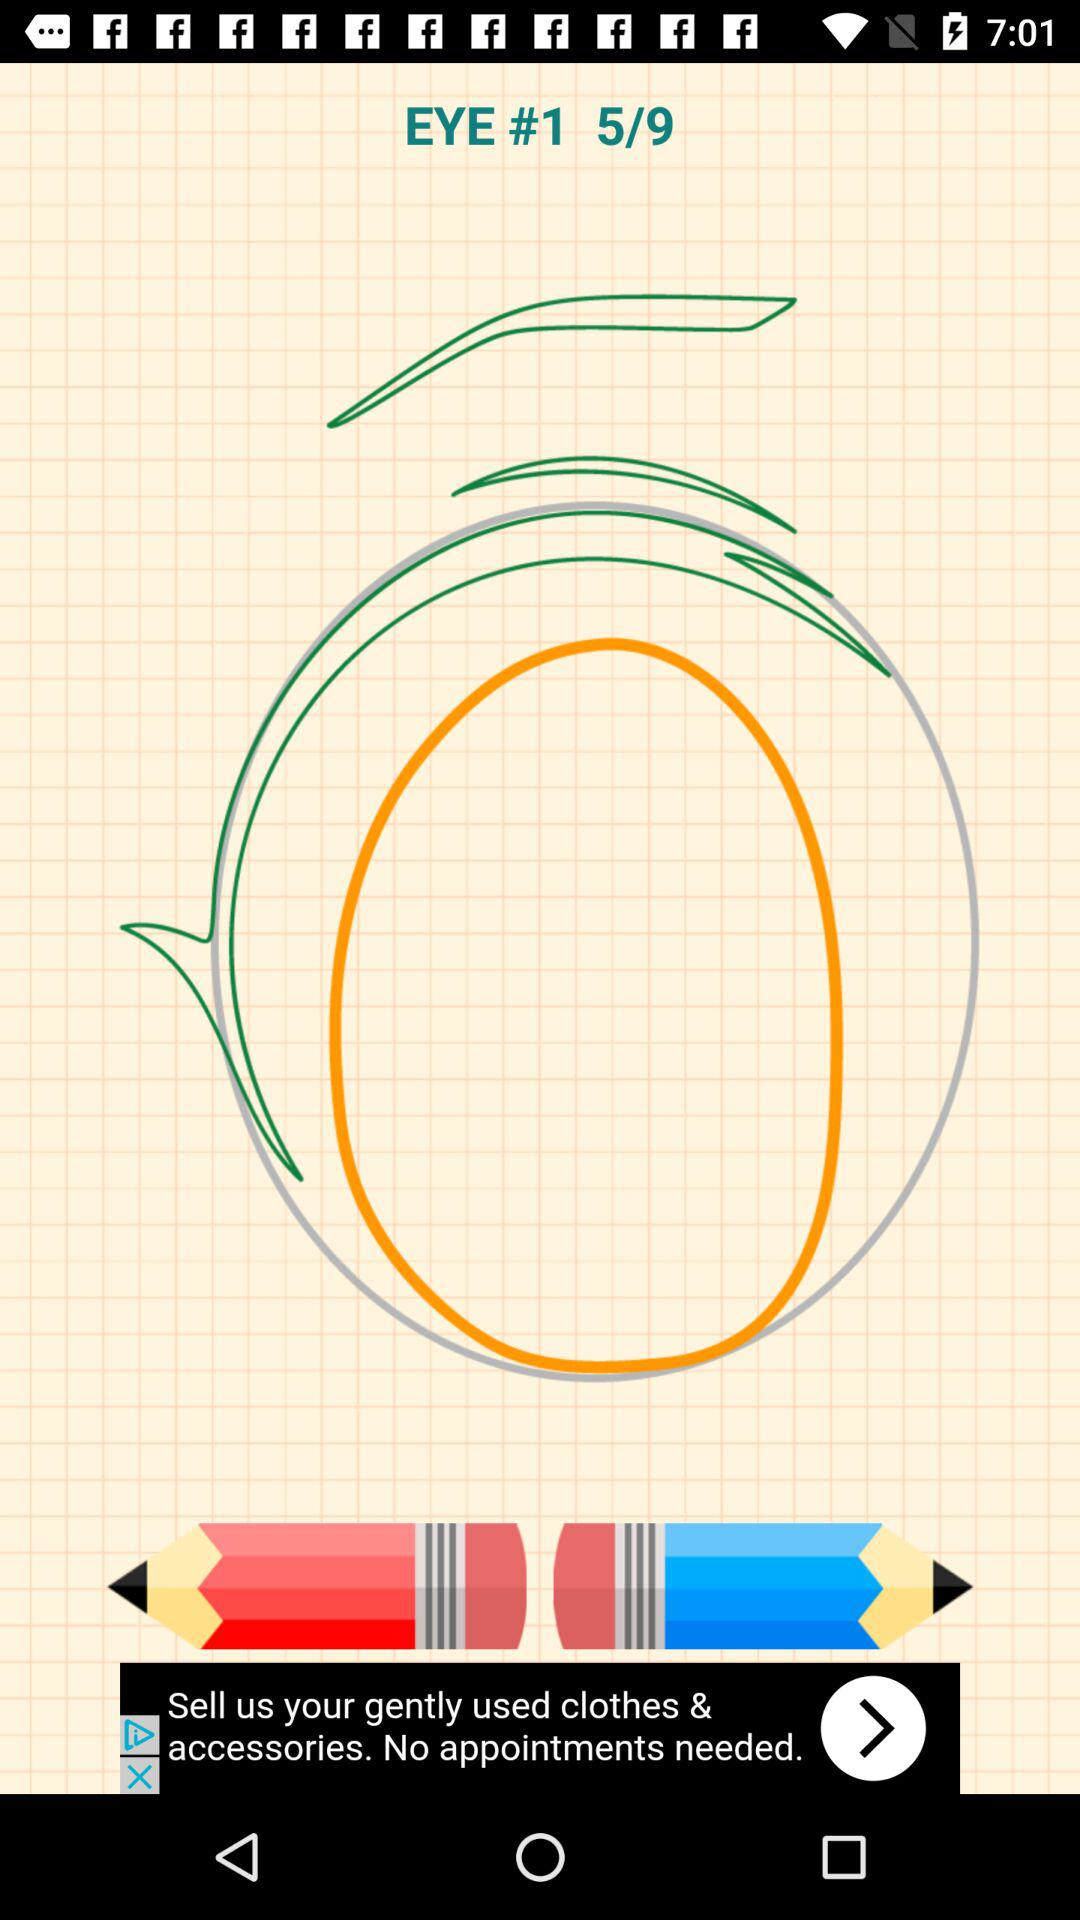On which page number are we currently? You are currently on page number 5. 